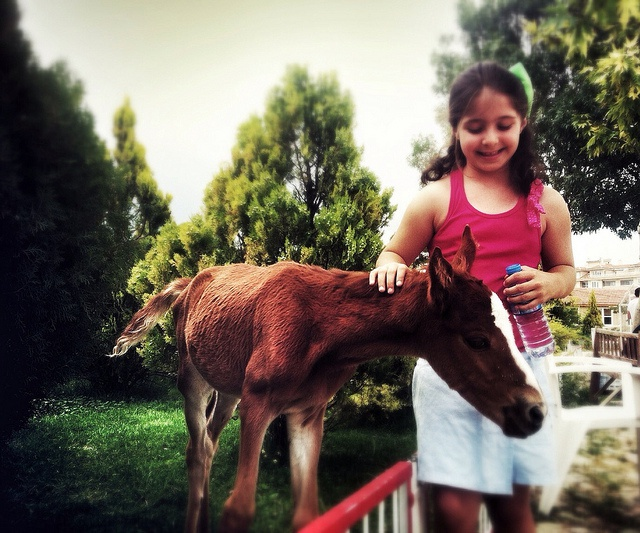Describe the objects in this image and their specific colors. I can see horse in black, maroon, and brown tones, people in black, lightgray, maroon, and brown tones, bench in black, gray, and maroon tones, bottle in black, brown, lightgray, and maroon tones, and people in black, ivory, and tan tones in this image. 